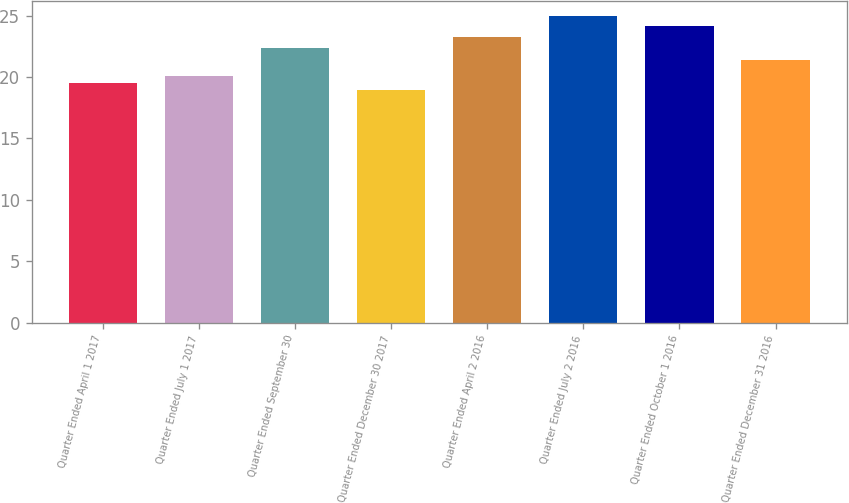Convert chart. <chart><loc_0><loc_0><loc_500><loc_500><bar_chart><fcel>Quarter Ended April 1 2017<fcel>Quarter Ended July 1 2017<fcel>Quarter Ended September 30<fcel>Quarter Ended December 30 2017<fcel>Quarter Ended April 2 2016<fcel>Quarter Ended July 2 2016<fcel>Quarter Ended October 1 2016<fcel>Quarter Ended December 31 2016<nl><fcel>19.51<fcel>20.12<fcel>22.38<fcel>18.9<fcel>23.25<fcel>24.96<fcel>24.14<fcel>21.4<nl></chart> 